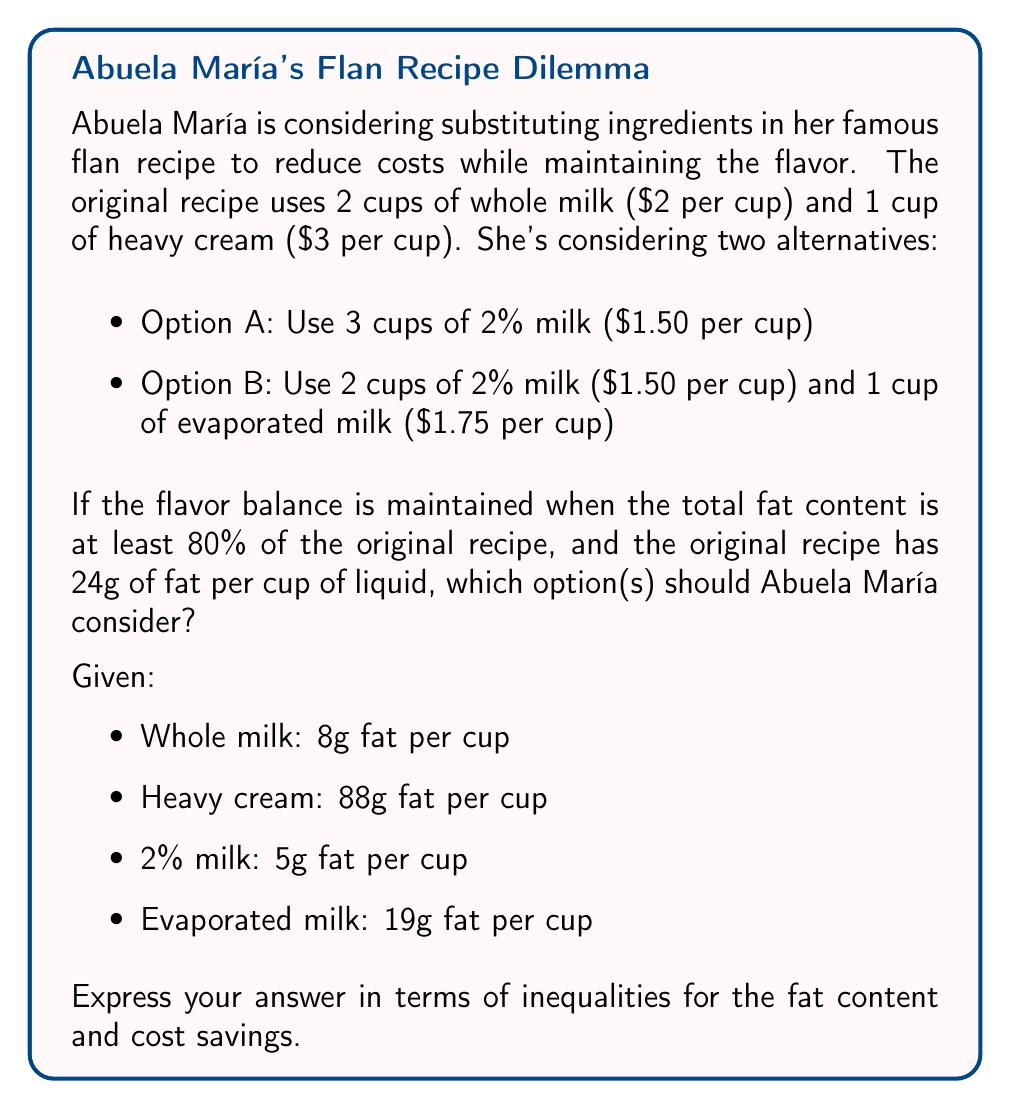Give your solution to this math problem. Let's approach this step-by-step:

1) Calculate the total fat and cost of the original recipe:
   Fat: $2(8g) + 1(88g) = 104g$
   Cost: $2($2) + 1($3) = $7$

2) Calculate 80% of the original fat content:
   $104g * 0.8 = 83.2g$

3) Option A:
   Fat: $3(5g) = 15g$
   Cost: $3($1.50) = $4.50$

4) Option B:
   Fat: $2(5g) + 1(19g) = 29g$
   Cost: $2($1.50) + 1($1.75) = $4.75$

5) Set up inequalities for fat content:
   Option A: $15g < 83.2g$
   Option B: $29g < 83.2g$

6) Calculate cost savings:
   Option A: $7 - $4.50 = $2.50$
   Option B: $7 - $4.75 = $2.25$

7) Set up inequalities for cost savings:
   Option A: $x \geq 2.50$, where $x$ is the cost saving
   Option B: $x \geq 2.25$, where $x$ is the cost saving

Neither option meets the fat content requirement, as both are less than 83.2g. However, both options provide cost savings.
Answer: Neither option should be considered as they both fail to meet the fat content requirement: $15g < 83.2g$ and $29g < 83.2g$. However, if only considering cost savings, both options are viable with Option A saving $x \geq $2.50$ and Option B saving $x \geq $2.25$, where $x$ is the cost saving. 